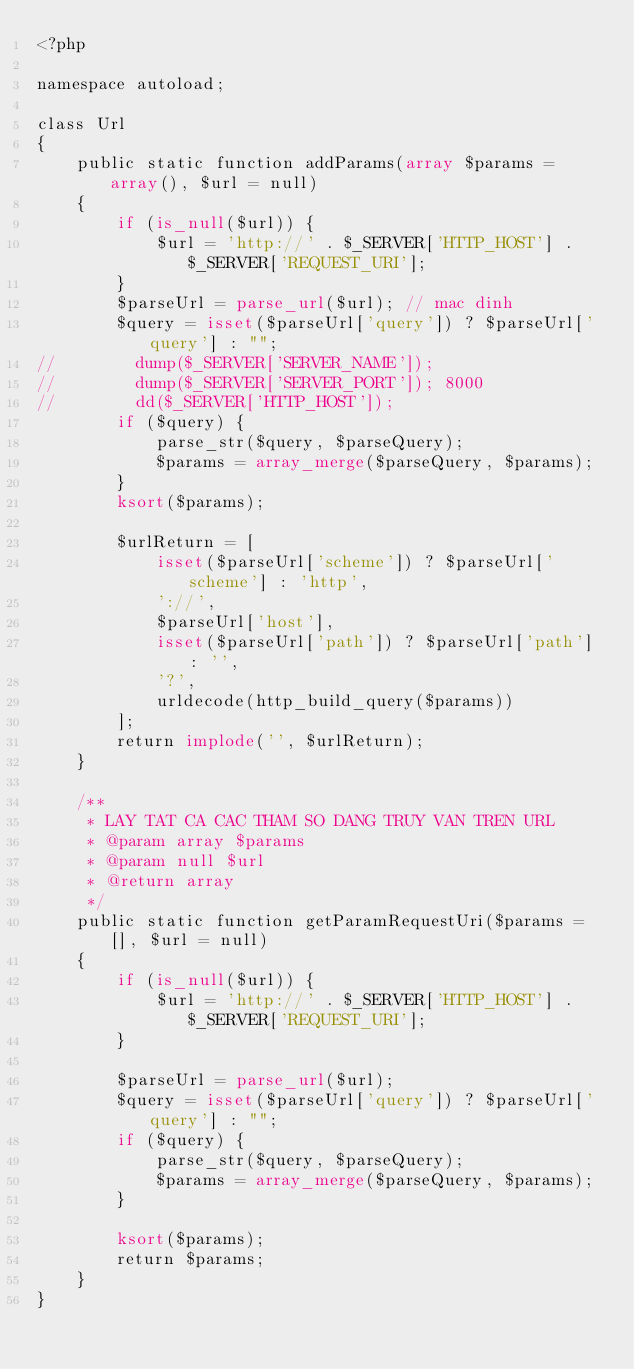Convert code to text. <code><loc_0><loc_0><loc_500><loc_500><_PHP_><?php

namespace autoload;

class Url
{
    public static function addParams(array $params = array(), $url = null)
    {
        if (is_null($url)) {
            $url = 'http://' . $_SERVER['HTTP_HOST'] . $_SERVER['REQUEST_URI'];
        }
        $parseUrl = parse_url($url); // mac dinh
        $query = isset($parseUrl['query']) ? $parseUrl['query'] : "";
//        dump($_SERVER['SERVER_NAME']);
//        dump($_SERVER['SERVER_PORT']); 8000
//        dd($_SERVER['HTTP_HOST']);
        if ($query) {
            parse_str($query, $parseQuery);
            $params = array_merge($parseQuery, $params);
        }
        ksort($params);

        $urlReturn = [
            isset($parseUrl['scheme']) ? $parseUrl['scheme'] : 'http',
            '://',
            $parseUrl['host'],
            isset($parseUrl['path']) ? $parseUrl['path'] : '',
            '?',
            urldecode(http_build_query($params))
        ];
        return implode('', $urlReturn);
    }

    /**
     * LAY TAT CA CAC THAM SO DANG TRUY VAN TREN URL
     * @param array $params
     * @param null $url
     * @return array
     */
    public static function getParamRequestUri($params = [], $url = null)
    {
        if (is_null($url)) {
            $url = 'http://' . $_SERVER['HTTP_HOST'] . $_SERVER['REQUEST_URI'];
        }

        $parseUrl = parse_url($url);
        $query = isset($parseUrl['query']) ? $parseUrl['query'] : "";
        if ($query) {
            parse_str($query, $parseQuery);
            $params = array_merge($parseQuery, $params);
        }

        ksort($params);
        return $params;
    }
}</code> 